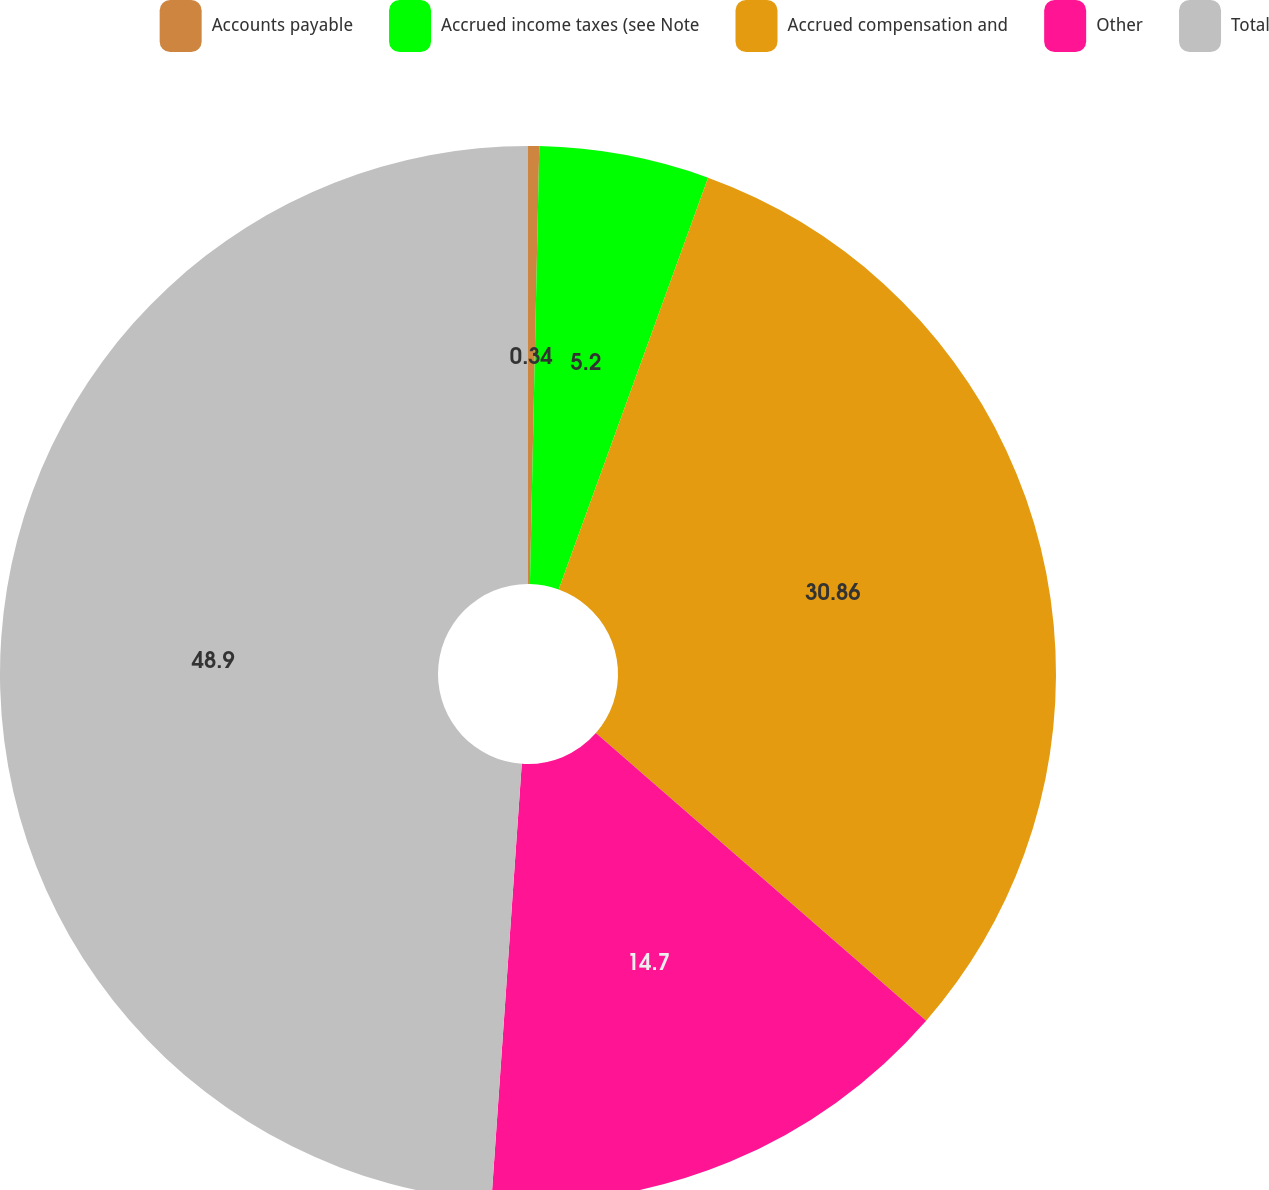Convert chart. <chart><loc_0><loc_0><loc_500><loc_500><pie_chart><fcel>Accounts payable<fcel>Accrued income taxes (see Note<fcel>Accrued compensation and<fcel>Other<fcel>Total<nl><fcel>0.34%<fcel>5.2%<fcel>30.86%<fcel>14.7%<fcel>48.89%<nl></chart> 